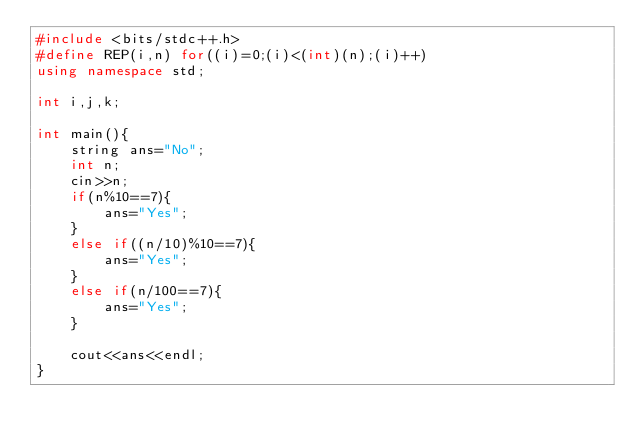Convert code to text. <code><loc_0><loc_0><loc_500><loc_500><_C++_>#include <bits/stdc++.h>
#define REP(i,n) for((i)=0;(i)<(int)(n);(i)++)
using namespace std;

int i,j,k;

int main(){
    string ans="No";
    int n;
    cin>>n;
    if(n%10==7){
        ans="Yes";
    }
    else if((n/10)%10==7){
        ans="Yes";
    }
    else if(n/100==7){
        ans="Yes";
    }
    
    cout<<ans<<endl;
}</code> 